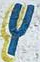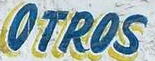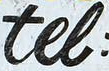What words are shown in these images in order, separated by a semicolon? Y; OTROS; tel 